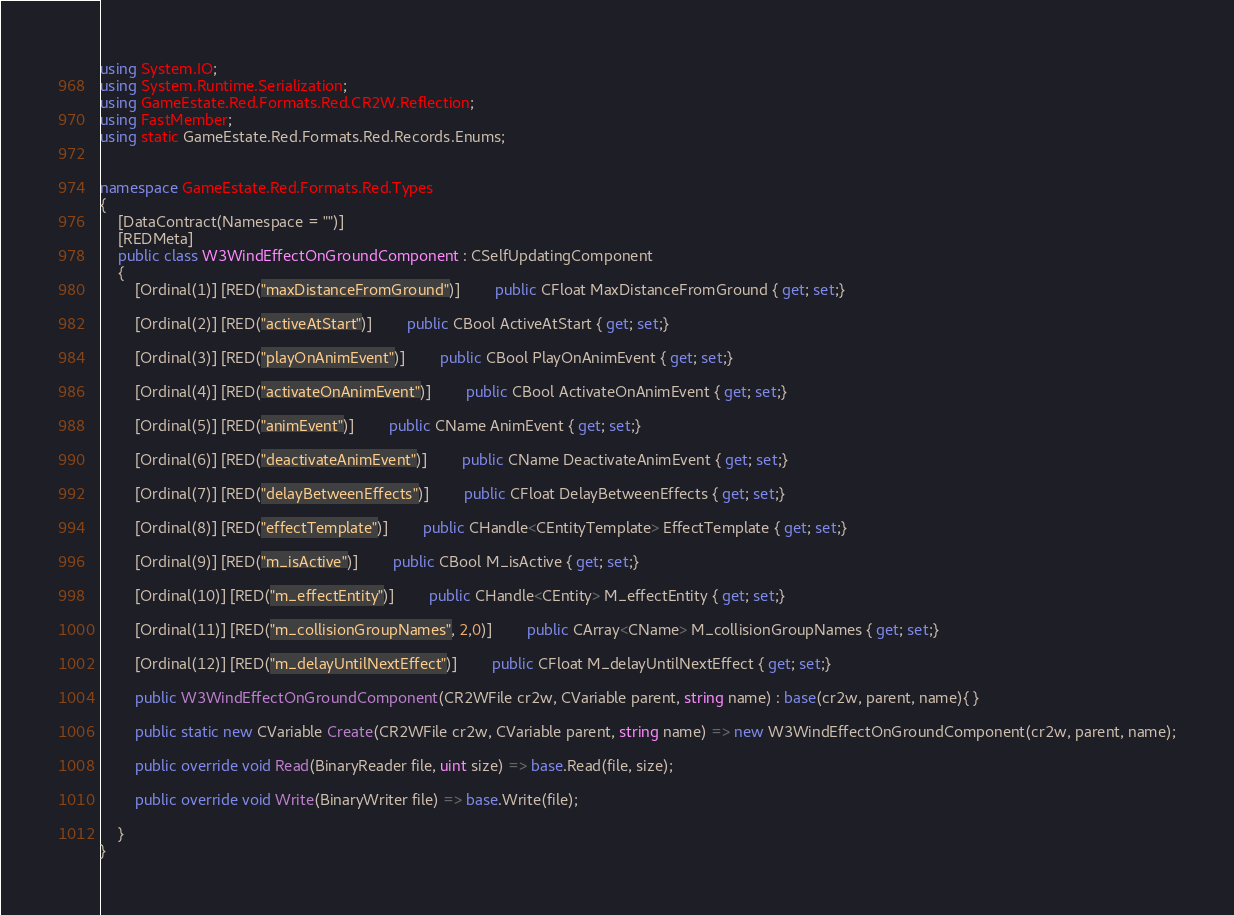<code> <loc_0><loc_0><loc_500><loc_500><_C#_>using System.IO;
using System.Runtime.Serialization;
using GameEstate.Red.Formats.Red.CR2W.Reflection;
using FastMember;
using static GameEstate.Red.Formats.Red.Records.Enums;


namespace GameEstate.Red.Formats.Red.Types
{
	[DataContract(Namespace = "")]
	[REDMeta]
	public class W3WindEffectOnGroundComponent : CSelfUpdatingComponent
	{
		[Ordinal(1)] [RED("maxDistanceFromGround")] 		public CFloat MaxDistanceFromGround { get; set;}

		[Ordinal(2)] [RED("activeAtStart")] 		public CBool ActiveAtStart { get; set;}

		[Ordinal(3)] [RED("playOnAnimEvent")] 		public CBool PlayOnAnimEvent { get; set;}

		[Ordinal(4)] [RED("activateOnAnimEvent")] 		public CBool ActivateOnAnimEvent { get; set;}

		[Ordinal(5)] [RED("animEvent")] 		public CName AnimEvent { get; set;}

		[Ordinal(6)] [RED("deactivateAnimEvent")] 		public CName DeactivateAnimEvent { get; set;}

		[Ordinal(7)] [RED("delayBetweenEffects")] 		public CFloat DelayBetweenEffects { get; set;}

		[Ordinal(8)] [RED("effectTemplate")] 		public CHandle<CEntityTemplate> EffectTemplate { get; set;}

		[Ordinal(9)] [RED("m_isActive")] 		public CBool M_isActive { get; set;}

		[Ordinal(10)] [RED("m_effectEntity")] 		public CHandle<CEntity> M_effectEntity { get; set;}

		[Ordinal(11)] [RED("m_collisionGroupNames", 2,0)] 		public CArray<CName> M_collisionGroupNames { get; set;}

		[Ordinal(12)] [RED("m_delayUntilNextEffect")] 		public CFloat M_delayUntilNextEffect { get; set;}

		public W3WindEffectOnGroundComponent(CR2WFile cr2w, CVariable parent, string name) : base(cr2w, parent, name){ }

		public static new CVariable Create(CR2WFile cr2w, CVariable parent, string name) => new W3WindEffectOnGroundComponent(cr2w, parent, name);

		public override void Read(BinaryReader file, uint size) => base.Read(file, size);

		public override void Write(BinaryWriter file) => base.Write(file);

	}
}</code> 